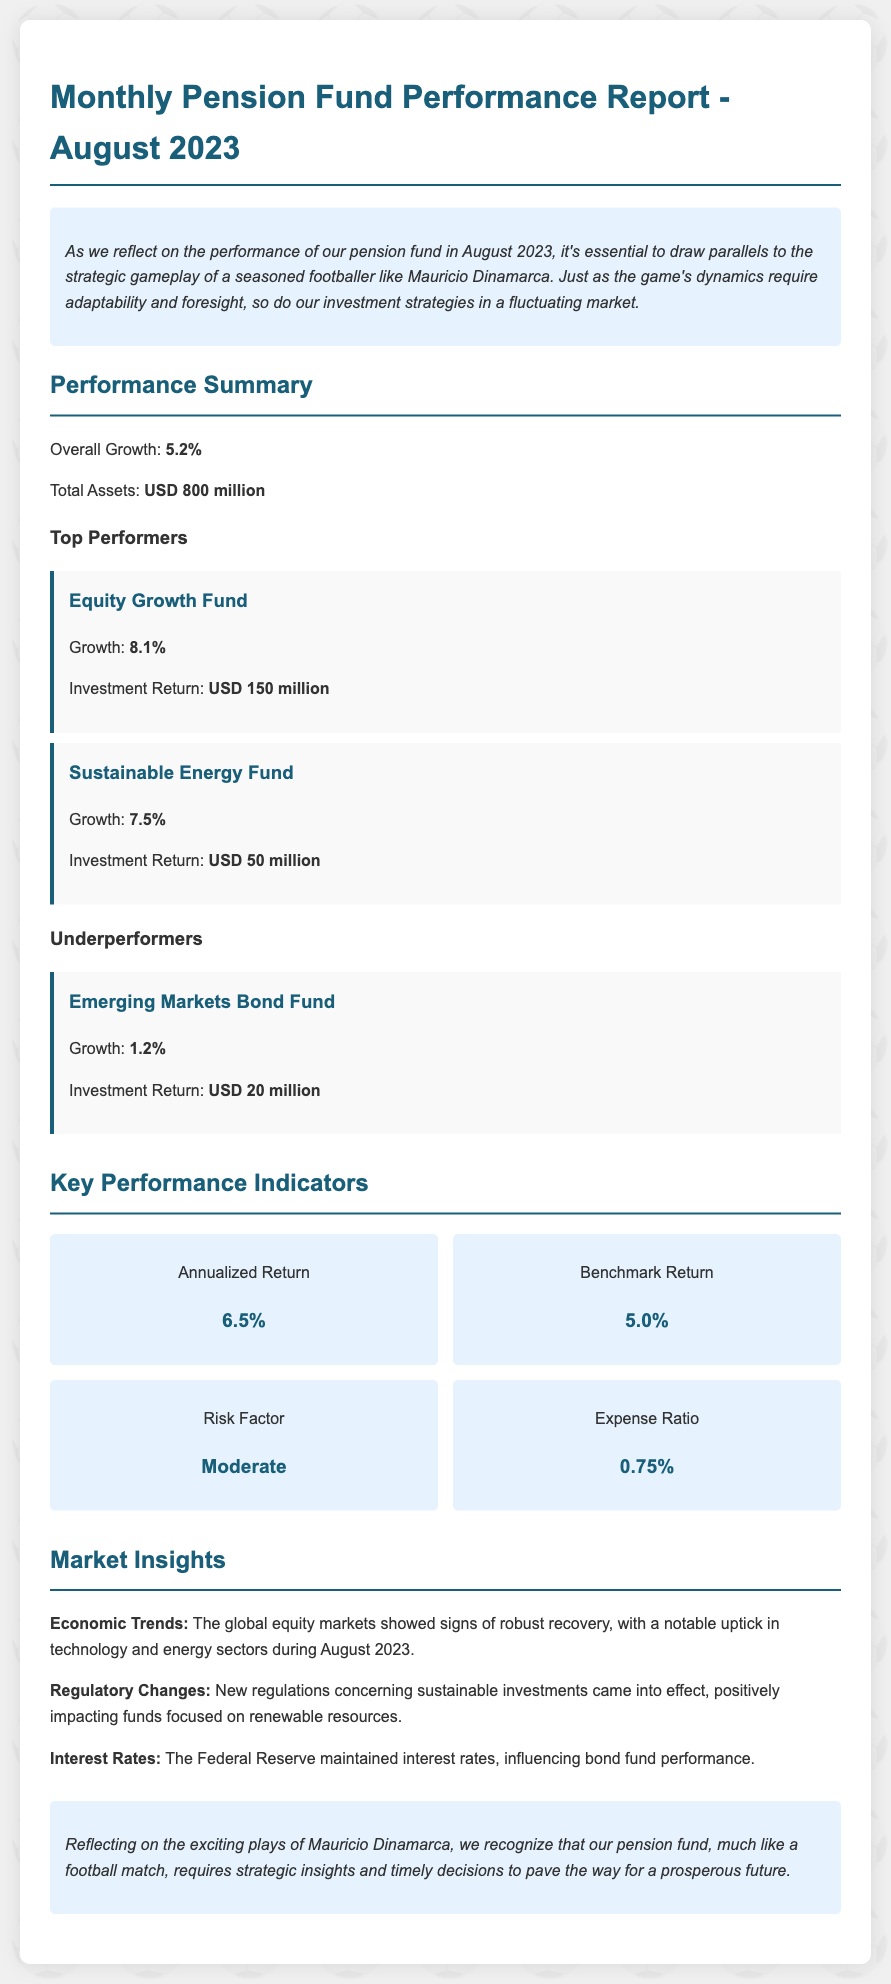What was the overall growth for August 2023? The overall growth is stated in the performance summary section of the document.
Answer: 5.2% What are the total assets reported? The total assets can be found under the performance summary section of the document.
Answer: USD 800 million Which fund had the highest growth? This information is found in the top performers section of the performance summary.
Answer: Equity Growth Fund What is the annualized return? The annualized return is a key performance indicator specified in the KPI section of the document.
Answer: 6.5% What is the expense ratio? The expense ratio is listed as a key performance indicator in the document.
Answer: 0.75% Which sector showed signs of recovery? The recovery of the sector can be derived from the market insights section.
Answer: Technology What kind of risk factor is mentioned? The risk factor is included in the KPI section of the document.
Answer: Moderate What was the growth percentage for the Sustainable Energy Fund? Details about the growth percentage for this fund are available in the top performers part of the summary.
Answer: 7.5% What were the regulatory changes related to? The regulatory changes are described in the market insights section of the document.
Answer: Sustainable investments 